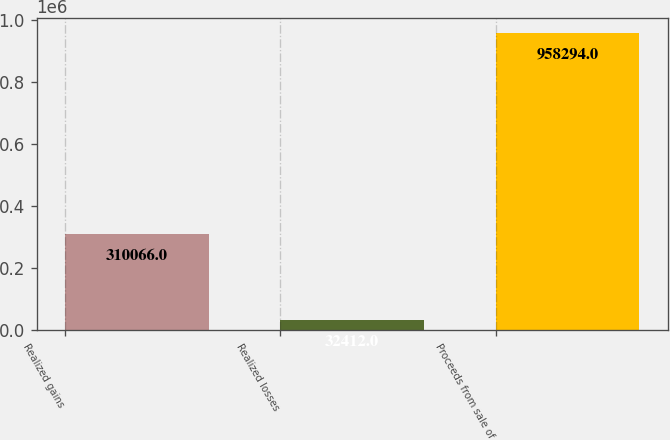Convert chart to OTSL. <chart><loc_0><loc_0><loc_500><loc_500><bar_chart><fcel>Realized gains<fcel>Realized losses<fcel>Proceeds from sale of<nl><fcel>310066<fcel>32412<fcel>958294<nl></chart> 